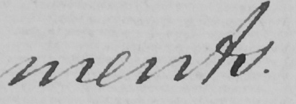What does this handwritten line say? ments . 